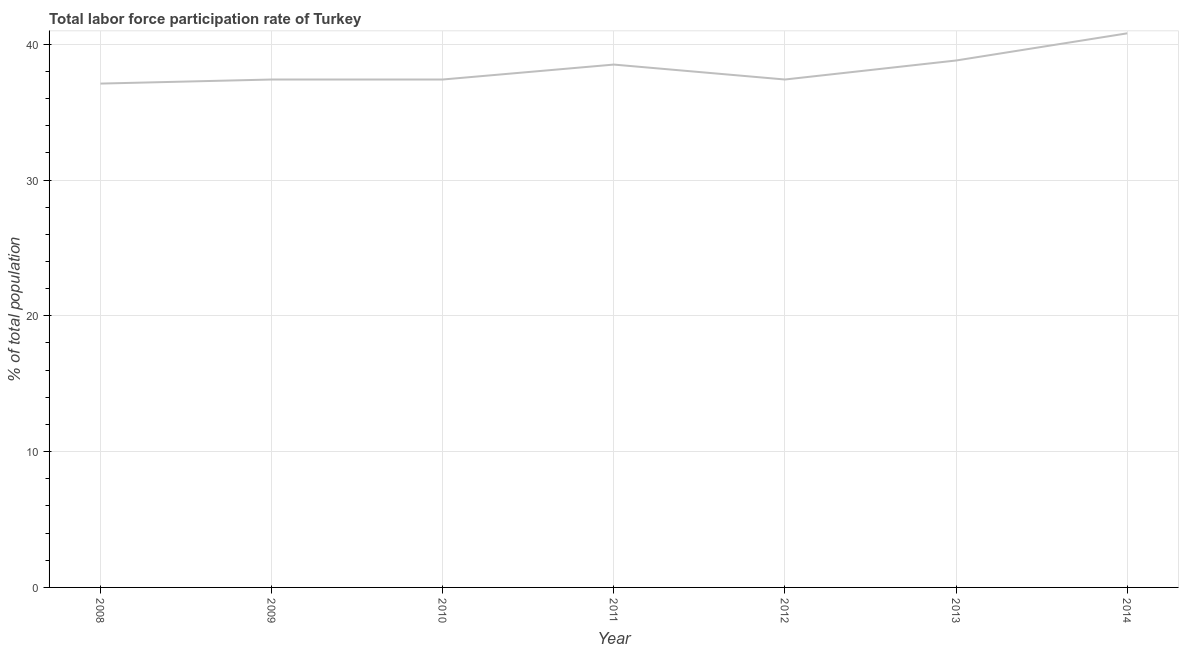What is the total labor force participation rate in 2010?
Provide a short and direct response. 37.4. Across all years, what is the maximum total labor force participation rate?
Make the answer very short. 40.8. Across all years, what is the minimum total labor force participation rate?
Make the answer very short. 37.1. In which year was the total labor force participation rate maximum?
Ensure brevity in your answer.  2014. In which year was the total labor force participation rate minimum?
Keep it short and to the point. 2008. What is the sum of the total labor force participation rate?
Offer a terse response. 267.4. What is the difference between the total labor force participation rate in 2010 and 2012?
Offer a terse response. 0. What is the average total labor force participation rate per year?
Ensure brevity in your answer.  38.2. What is the median total labor force participation rate?
Make the answer very short. 37.4. In how many years, is the total labor force participation rate greater than 36 %?
Your answer should be very brief. 7. Do a majority of the years between 2009 and 2012 (inclusive) have total labor force participation rate greater than 28 %?
Make the answer very short. Yes. What is the ratio of the total labor force participation rate in 2012 to that in 2014?
Offer a terse response. 0.92. Is the difference between the total labor force participation rate in 2009 and 2013 greater than the difference between any two years?
Provide a succinct answer. No. What is the difference between the highest and the second highest total labor force participation rate?
Ensure brevity in your answer.  2. Is the sum of the total labor force participation rate in 2010 and 2013 greater than the maximum total labor force participation rate across all years?
Offer a very short reply. Yes. What is the difference between the highest and the lowest total labor force participation rate?
Give a very brief answer. 3.7. In how many years, is the total labor force participation rate greater than the average total labor force participation rate taken over all years?
Provide a short and direct response. 3. How many years are there in the graph?
Your answer should be compact. 7. What is the difference between two consecutive major ticks on the Y-axis?
Your answer should be very brief. 10. Are the values on the major ticks of Y-axis written in scientific E-notation?
Your response must be concise. No. Does the graph contain any zero values?
Provide a short and direct response. No. What is the title of the graph?
Your answer should be compact. Total labor force participation rate of Turkey. What is the label or title of the X-axis?
Offer a very short reply. Year. What is the label or title of the Y-axis?
Your response must be concise. % of total population. What is the % of total population in 2008?
Your answer should be very brief. 37.1. What is the % of total population in 2009?
Your answer should be very brief. 37.4. What is the % of total population in 2010?
Your answer should be compact. 37.4. What is the % of total population in 2011?
Your answer should be very brief. 38.5. What is the % of total population of 2012?
Offer a very short reply. 37.4. What is the % of total population of 2013?
Make the answer very short. 38.8. What is the % of total population of 2014?
Keep it short and to the point. 40.8. What is the difference between the % of total population in 2008 and 2009?
Your response must be concise. -0.3. What is the difference between the % of total population in 2008 and 2012?
Your answer should be very brief. -0.3. What is the difference between the % of total population in 2008 and 2014?
Provide a short and direct response. -3.7. What is the difference between the % of total population in 2009 and 2010?
Your response must be concise. 0. What is the difference between the % of total population in 2009 and 2011?
Your response must be concise. -1.1. What is the difference between the % of total population in 2009 and 2012?
Provide a short and direct response. 0. What is the difference between the % of total population in 2009 and 2013?
Ensure brevity in your answer.  -1.4. What is the difference between the % of total population in 2009 and 2014?
Ensure brevity in your answer.  -3.4. What is the difference between the % of total population in 2010 and 2013?
Your answer should be very brief. -1.4. What is the difference between the % of total population in 2011 and 2012?
Give a very brief answer. 1.1. What is the difference between the % of total population in 2011 and 2014?
Offer a very short reply. -2.3. What is the ratio of the % of total population in 2008 to that in 2009?
Keep it short and to the point. 0.99. What is the ratio of the % of total population in 2008 to that in 2010?
Keep it short and to the point. 0.99. What is the ratio of the % of total population in 2008 to that in 2011?
Ensure brevity in your answer.  0.96. What is the ratio of the % of total population in 2008 to that in 2012?
Ensure brevity in your answer.  0.99. What is the ratio of the % of total population in 2008 to that in 2013?
Your answer should be compact. 0.96. What is the ratio of the % of total population in 2008 to that in 2014?
Ensure brevity in your answer.  0.91. What is the ratio of the % of total population in 2009 to that in 2010?
Provide a short and direct response. 1. What is the ratio of the % of total population in 2009 to that in 2013?
Your response must be concise. 0.96. What is the ratio of the % of total population in 2009 to that in 2014?
Offer a terse response. 0.92. What is the ratio of the % of total population in 2010 to that in 2011?
Your response must be concise. 0.97. What is the ratio of the % of total population in 2010 to that in 2013?
Ensure brevity in your answer.  0.96. What is the ratio of the % of total population in 2010 to that in 2014?
Your response must be concise. 0.92. What is the ratio of the % of total population in 2011 to that in 2014?
Your answer should be very brief. 0.94. What is the ratio of the % of total population in 2012 to that in 2013?
Provide a short and direct response. 0.96. What is the ratio of the % of total population in 2012 to that in 2014?
Give a very brief answer. 0.92. What is the ratio of the % of total population in 2013 to that in 2014?
Offer a very short reply. 0.95. 